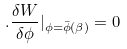Convert formula to latex. <formula><loc_0><loc_0><loc_500><loc_500>. \frac { \delta W } { \delta \phi } | _ { \phi = \bar { \phi } ( \beta ) } = 0</formula> 